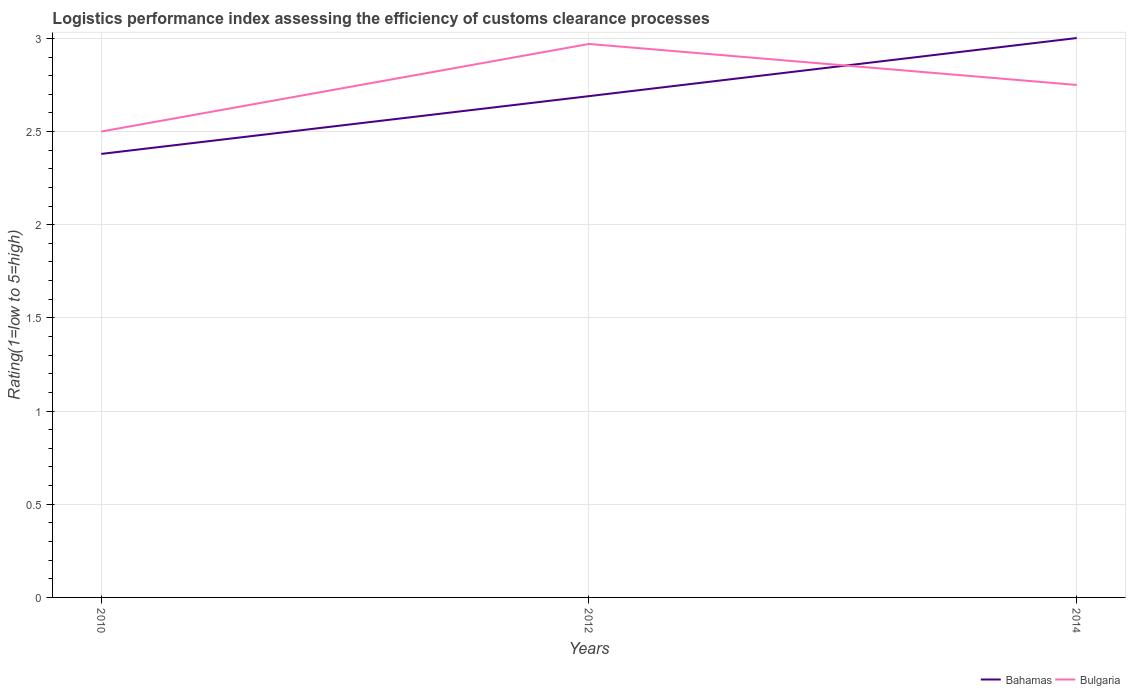Is the number of lines equal to the number of legend labels?
Your answer should be very brief. Yes. Across all years, what is the maximum Logistic performance index in Bahamas?
Provide a succinct answer. 2.38. What is the total Logistic performance index in Bahamas in the graph?
Offer a terse response. -0.62. What is the difference between the highest and the second highest Logistic performance index in Bulgaria?
Provide a short and direct response. 0.47. Is the Logistic performance index in Bahamas strictly greater than the Logistic performance index in Bulgaria over the years?
Your answer should be very brief. No. How many lines are there?
Give a very brief answer. 2. How many years are there in the graph?
Ensure brevity in your answer.  3. Are the values on the major ticks of Y-axis written in scientific E-notation?
Provide a short and direct response. No. Does the graph contain any zero values?
Offer a very short reply. No. Does the graph contain grids?
Your response must be concise. Yes. Where does the legend appear in the graph?
Provide a short and direct response. Bottom right. How many legend labels are there?
Make the answer very short. 2. What is the title of the graph?
Provide a succinct answer. Logistics performance index assessing the efficiency of customs clearance processes. What is the label or title of the Y-axis?
Keep it short and to the point. Rating(1=low to 5=high). What is the Rating(1=low to 5=high) of Bahamas in 2010?
Provide a short and direct response. 2.38. What is the Rating(1=low to 5=high) in Bulgaria in 2010?
Give a very brief answer. 2.5. What is the Rating(1=low to 5=high) in Bahamas in 2012?
Provide a short and direct response. 2.69. What is the Rating(1=low to 5=high) of Bulgaria in 2012?
Provide a short and direct response. 2.97. What is the Rating(1=low to 5=high) in Bahamas in 2014?
Provide a short and direct response. 3. What is the Rating(1=low to 5=high) of Bulgaria in 2014?
Provide a short and direct response. 2.75. Across all years, what is the maximum Rating(1=low to 5=high) of Bahamas?
Your response must be concise. 3. Across all years, what is the maximum Rating(1=low to 5=high) in Bulgaria?
Your answer should be very brief. 2.97. Across all years, what is the minimum Rating(1=low to 5=high) in Bahamas?
Provide a succinct answer. 2.38. What is the total Rating(1=low to 5=high) in Bahamas in the graph?
Keep it short and to the point. 8.07. What is the total Rating(1=low to 5=high) in Bulgaria in the graph?
Make the answer very short. 8.22. What is the difference between the Rating(1=low to 5=high) of Bahamas in 2010 and that in 2012?
Give a very brief answer. -0.31. What is the difference between the Rating(1=low to 5=high) in Bulgaria in 2010 and that in 2012?
Make the answer very short. -0.47. What is the difference between the Rating(1=low to 5=high) in Bahamas in 2010 and that in 2014?
Give a very brief answer. -0.62. What is the difference between the Rating(1=low to 5=high) in Bahamas in 2012 and that in 2014?
Your answer should be compact. -0.31. What is the difference between the Rating(1=low to 5=high) in Bulgaria in 2012 and that in 2014?
Ensure brevity in your answer.  0.22. What is the difference between the Rating(1=low to 5=high) of Bahamas in 2010 and the Rating(1=low to 5=high) of Bulgaria in 2012?
Provide a short and direct response. -0.59. What is the difference between the Rating(1=low to 5=high) in Bahamas in 2010 and the Rating(1=low to 5=high) in Bulgaria in 2014?
Provide a succinct answer. -0.37. What is the difference between the Rating(1=low to 5=high) of Bahamas in 2012 and the Rating(1=low to 5=high) of Bulgaria in 2014?
Make the answer very short. -0.06. What is the average Rating(1=low to 5=high) of Bahamas per year?
Ensure brevity in your answer.  2.69. What is the average Rating(1=low to 5=high) of Bulgaria per year?
Provide a succinct answer. 2.74. In the year 2010, what is the difference between the Rating(1=low to 5=high) of Bahamas and Rating(1=low to 5=high) of Bulgaria?
Offer a very short reply. -0.12. In the year 2012, what is the difference between the Rating(1=low to 5=high) in Bahamas and Rating(1=low to 5=high) in Bulgaria?
Keep it short and to the point. -0.28. In the year 2014, what is the difference between the Rating(1=low to 5=high) in Bahamas and Rating(1=low to 5=high) in Bulgaria?
Make the answer very short. 0.25. What is the ratio of the Rating(1=low to 5=high) of Bahamas in 2010 to that in 2012?
Your answer should be very brief. 0.88. What is the ratio of the Rating(1=low to 5=high) of Bulgaria in 2010 to that in 2012?
Provide a succinct answer. 0.84. What is the ratio of the Rating(1=low to 5=high) in Bahamas in 2010 to that in 2014?
Offer a very short reply. 0.79. What is the ratio of the Rating(1=low to 5=high) of Bahamas in 2012 to that in 2014?
Your answer should be compact. 0.9. What is the ratio of the Rating(1=low to 5=high) of Bulgaria in 2012 to that in 2014?
Offer a terse response. 1.08. What is the difference between the highest and the second highest Rating(1=low to 5=high) of Bahamas?
Your answer should be compact. 0.31. What is the difference between the highest and the second highest Rating(1=low to 5=high) of Bulgaria?
Ensure brevity in your answer.  0.22. What is the difference between the highest and the lowest Rating(1=low to 5=high) of Bahamas?
Offer a very short reply. 0.62. What is the difference between the highest and the lowest Rating(1=low to 5=high) in Bulgaria?
Offer a very short reply. 0.47. 